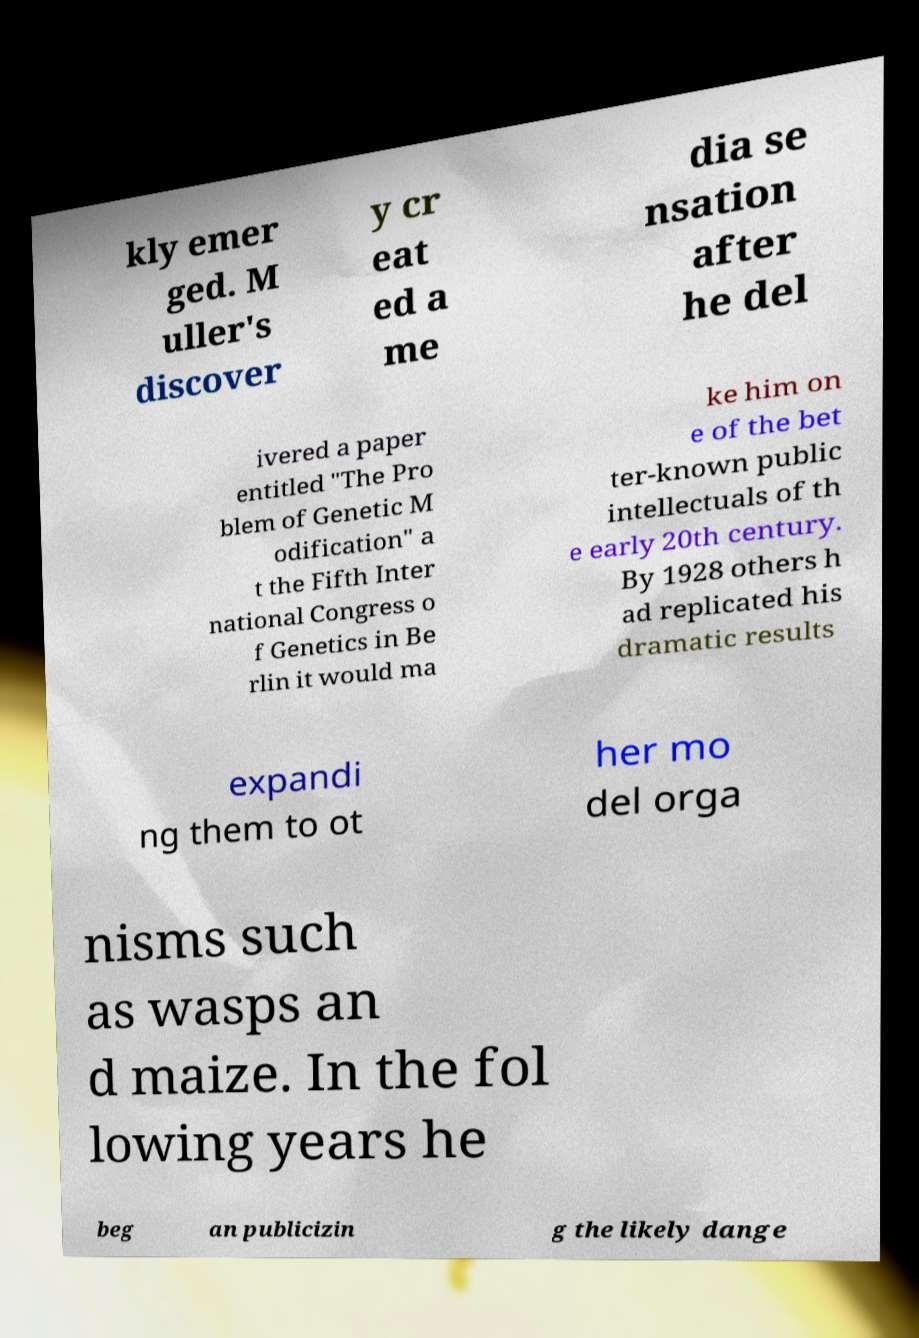There's text embedded in this image that I need extracted. Can you transcribe it verbatim? kly emer ged. M uller's discover y cr eat ed a me dia se nsation after he del ivered a paper entitled "The Pro blem of Genetic M odification" a t the Fifth Inter national Congress o f Genetics in Be rlin it would ma ke him on e of the bet ter-known public intellectuals of th e early 20th century. By 1928 others h ad replicated his dramatic results expandi ng them to ot her mo del orga nisms such as wasps an d maize. In the fol lowing years he beg an publicizin g the likely dange 